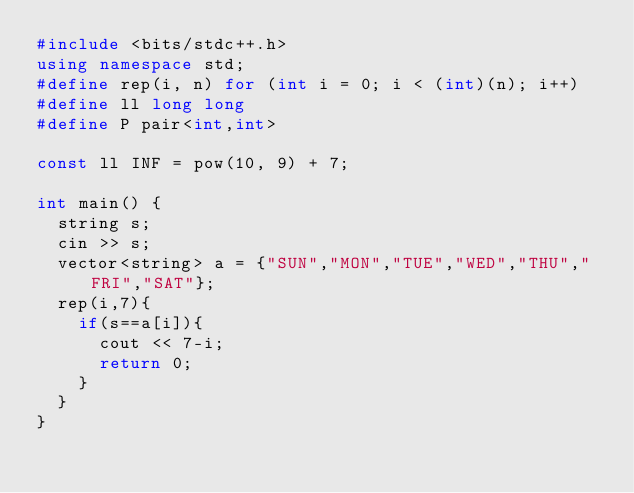Convert code to text. <code><loc_0><loc_0><loc_500><loc_500><_C++_>#include <bits/stdc++.h>
using namespace std;
#define rep(i, n) for (int i = 0; i < (int)(n); i++)
#define ll long long
#define P pair<int,int>

const ll INF = pow(10, 9) + 7;

int main() {
  string s;
  cin >> s;
  vector<string> a = {"SUN","MON","TUE","WED","THU","FRI","SAT"};
  rep(i,7){
    if(s==a[i]){
      cout << 7-i;
      return 0;
    }
  }
}</code> 